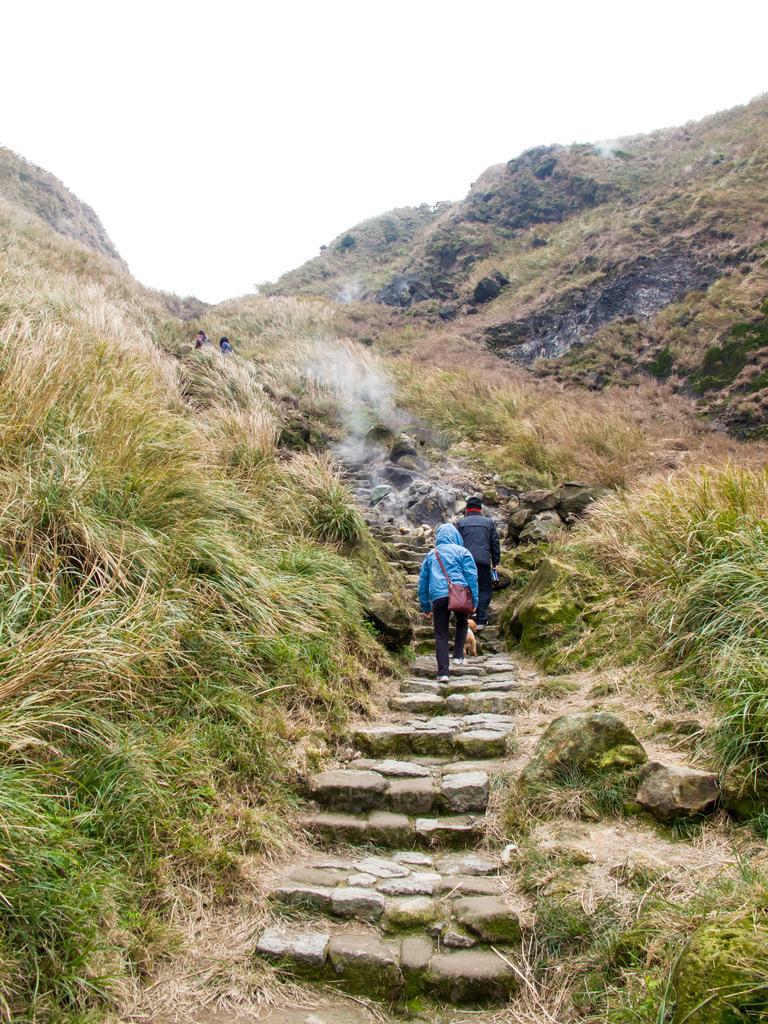Could you give a brief overview of what you see in this image? In this image, we can see two persons are walking through the steps. Here we can see plants, grass, smoke, people and hills. Top of the image, there is the sky. 